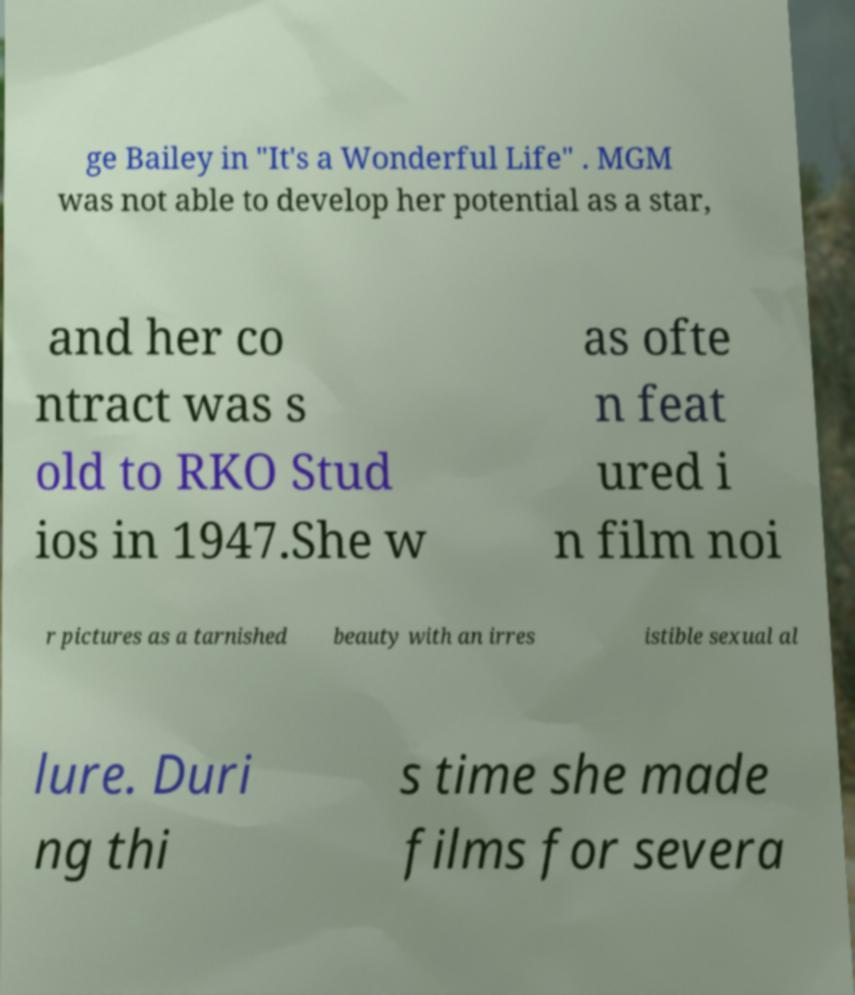I need the written content from this picture converted into text. Can you do that? ge Bailey in "It's a Wonderful Life" . MGM was not able to develop her potential as a star, and her co ntract was s old to RKO Stud ios in 1947.She w as ofte n feat ured i n film noi r pictures as a tarnished beauty with an irres istible sexual al lure. Duri ng thi s time she made films for severa 